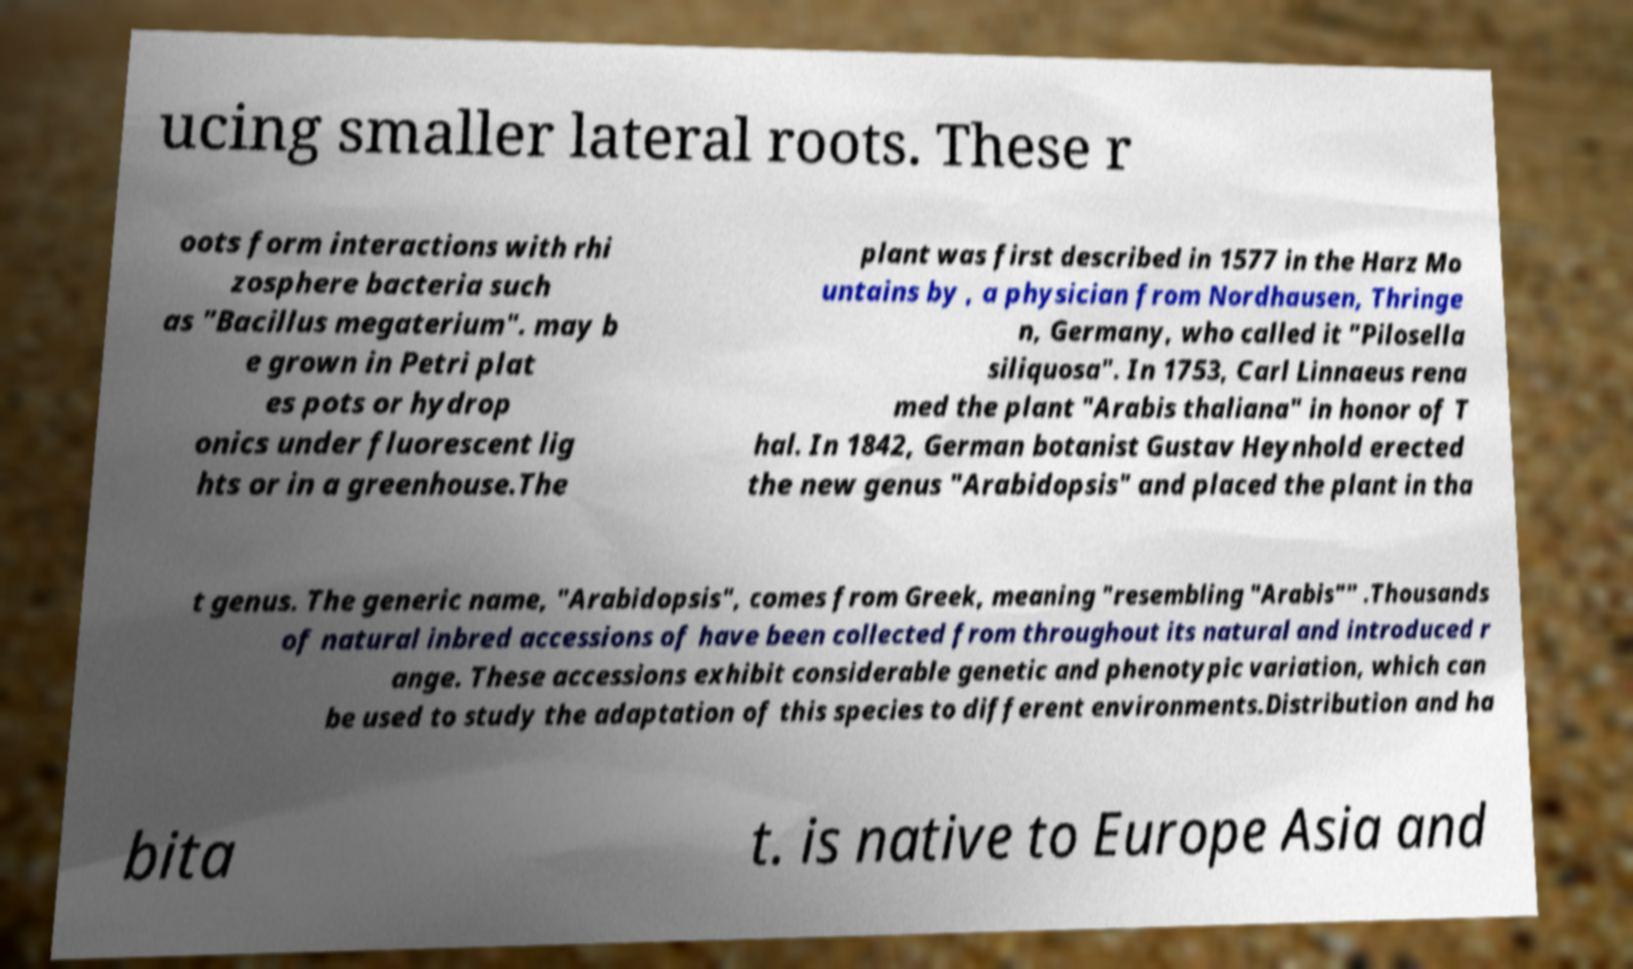There's text embedded in this image that I need extracted. Can you transcribe it verbatim? ucing smaller lateral roots. These r oots form interactions with rhi zosphere bacteria such as "Bacillus megaterium". may b e grown in Petri plat es pots or hydrop onics under fluorescent lig hts or in a greenhouse.The plant was first described in 1577 in the Harz Mo untains by , a physician from Nordhausen, Thringe n, Germany, who called it "Pilosella siliquosa". In 1753, Carl Linnaeus rena med the plant "Arabis thaliana" in honor of T hal. In 1842, German botanist Gustav Heynhold erected the new genus "Arabidopsis" and placed the plant in tha t genus. The generic name, "Arabidopsis", comes from Greek, meaning "resembling "Arabis"" .Thousands of natural inbred accessions of have been collected from throughout its natural and introduced r ange. These accessions exhibit considerable genetic and phenotypic variation, which can be used to study the adaptation of this species to different environments.Distribution and ha bita t. is native to Europe Asia and 